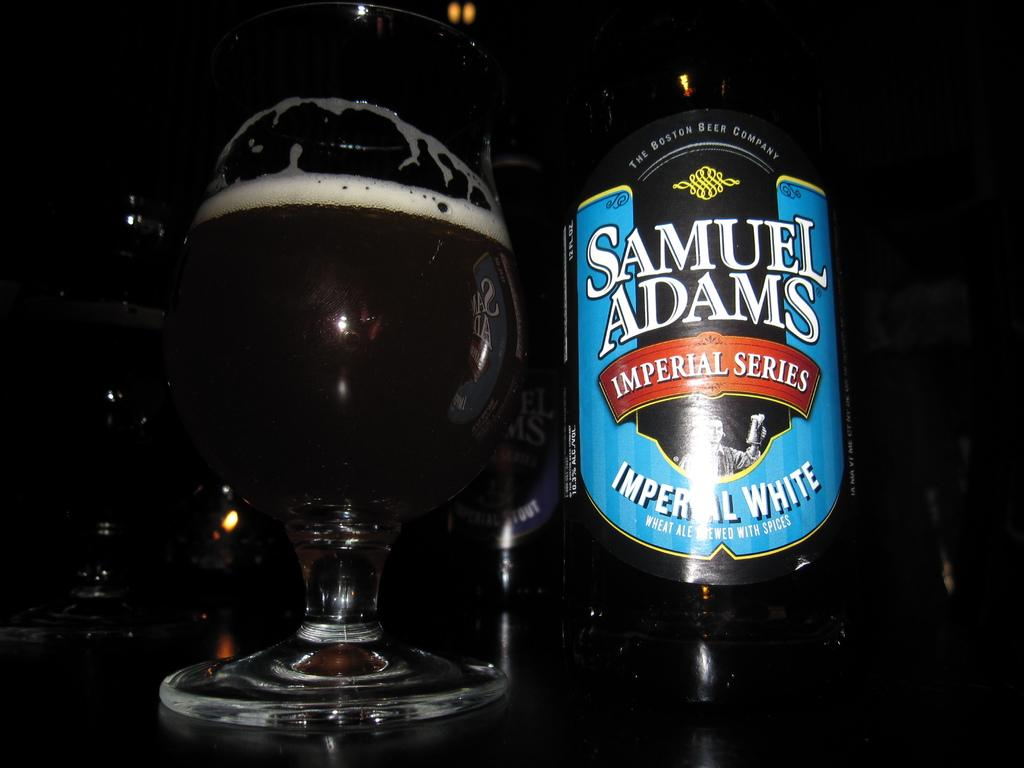<image>
Give a short and clear explanation of the subsequent image. A bottle of Samuel Adams sitting on a table. 